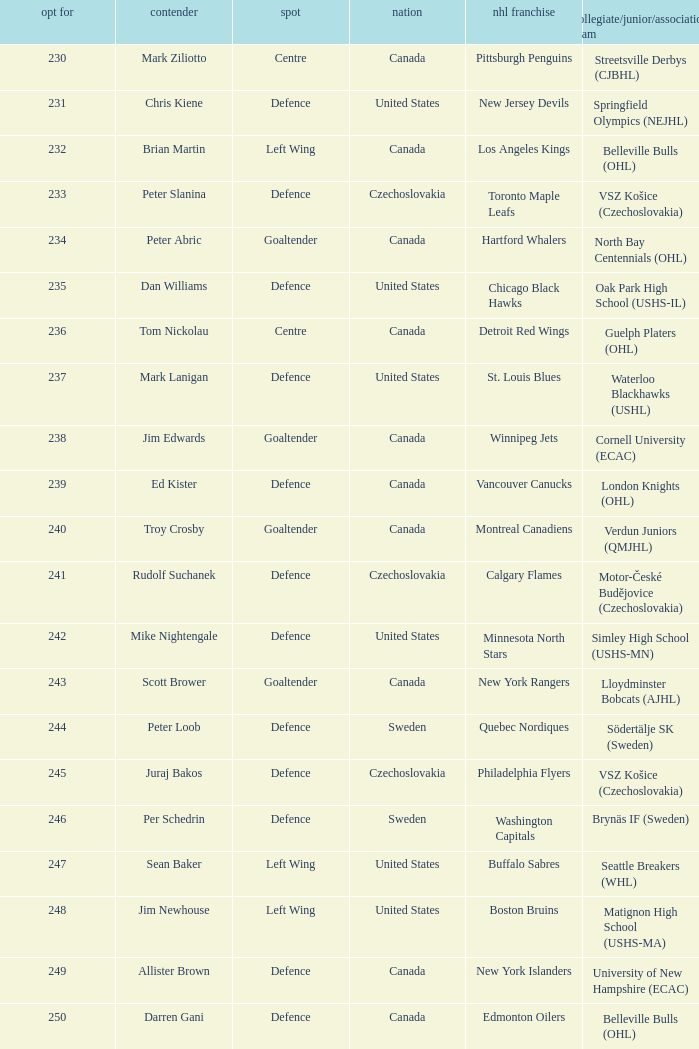Which draft number did the new jersey devils get? 231.0. 